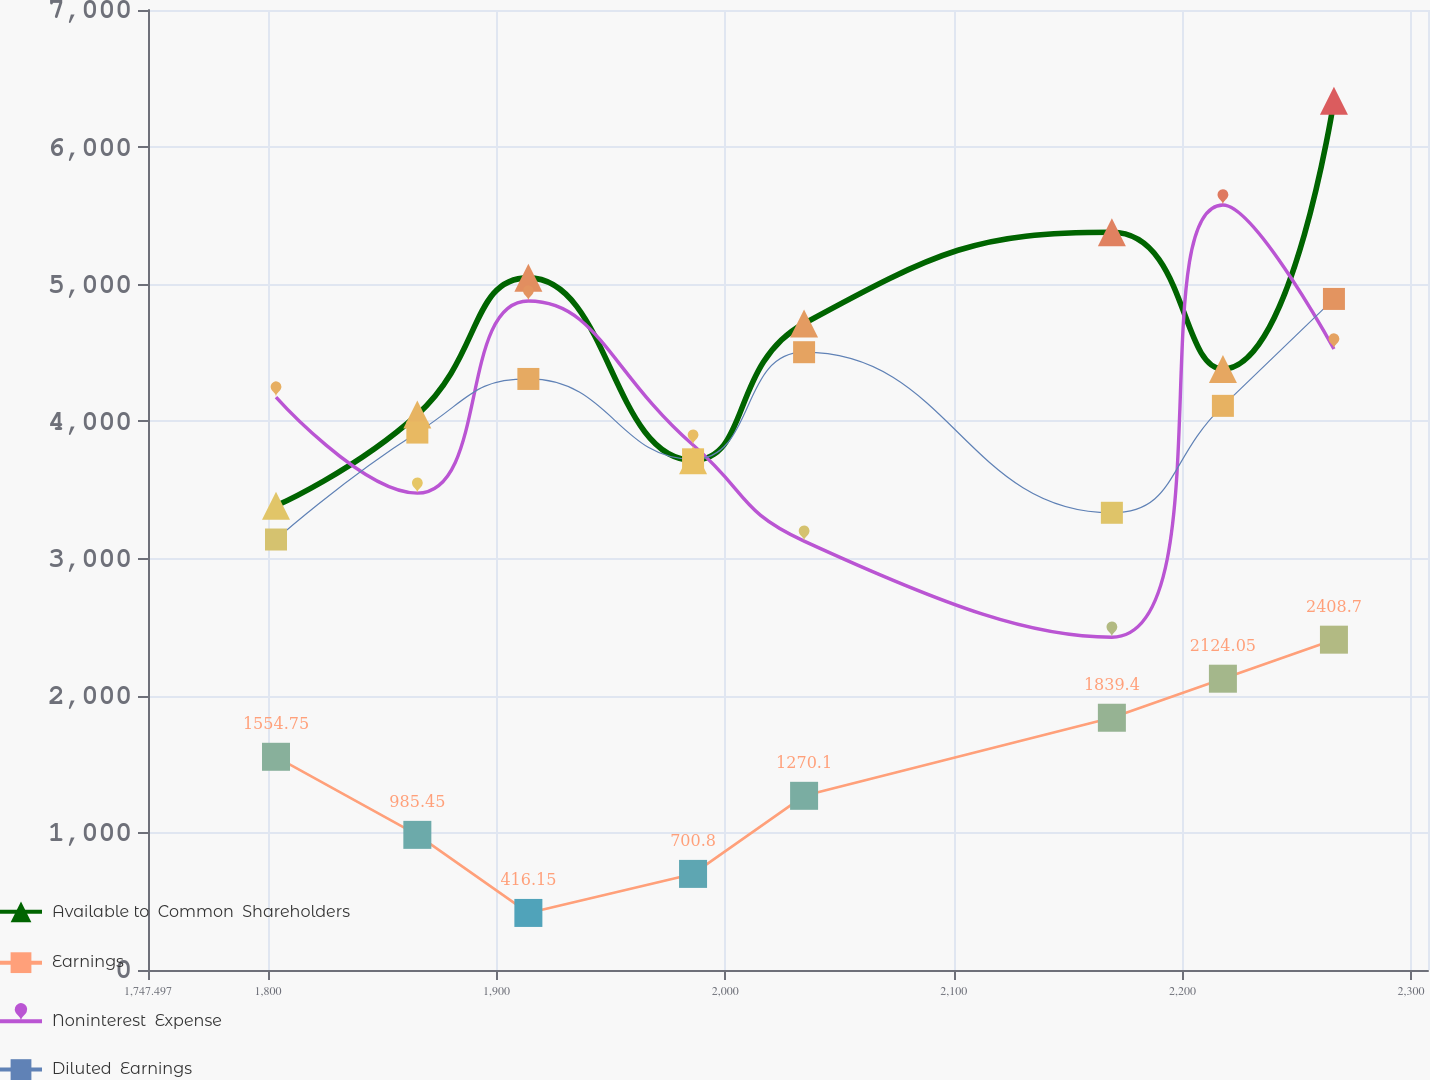Convert chart to OTSL. <chart><loc_0><loc_0><loc_500><loc_500><line_chart><ecel><fcel>Available to  Common  Shareholders<fcel>Earnings<fcel>Noninterest  Expense<fcel>Diluted  Earnings<nl><fcel>1803.49<fcel>3384.95<fcel>1554.75<fcel>4177.71<fcel>3139.04<nl><fcel>1865.32<fcel>4049.73<fcel>985.45<fcel>3477.35<fcel>3918.72<nl><fcel>1913.89<fcel>5046.9<fcel>416.15<fcel>4878.07<fcel>4309.77<nl><fcel>1985.93<fcel>3717.34<fcel>700.8<fcel>3827.53<fcel>3723.8<nl><fcel>2034.5<fcel>4714.51<fcel>1270.1<fcel>3127.17<fcel>4504.69<nl><fcel>2169.14<fcel>5379.29<fcel>1839.4<fcel>2426.81<fcel>3333.96<nl><fcel>2217.71<fcel>4382.12<fcel>2124.05<fcel>5578.46<fcel>4113.64<nl><fcel>2266.28<fcel>6339.15<fcel>2408.7<fcel>4527.89<fcel>4893.28<nl><fcel>2314.85<fcel>6006.76<fcel>2998.34<fcel>2076.63<fcel>2944.12<nl><fcel>2363.42<fcel>6708.84<fcel>3282.99<fcel>2776.99<fcel>3528.88<nl></chart> 